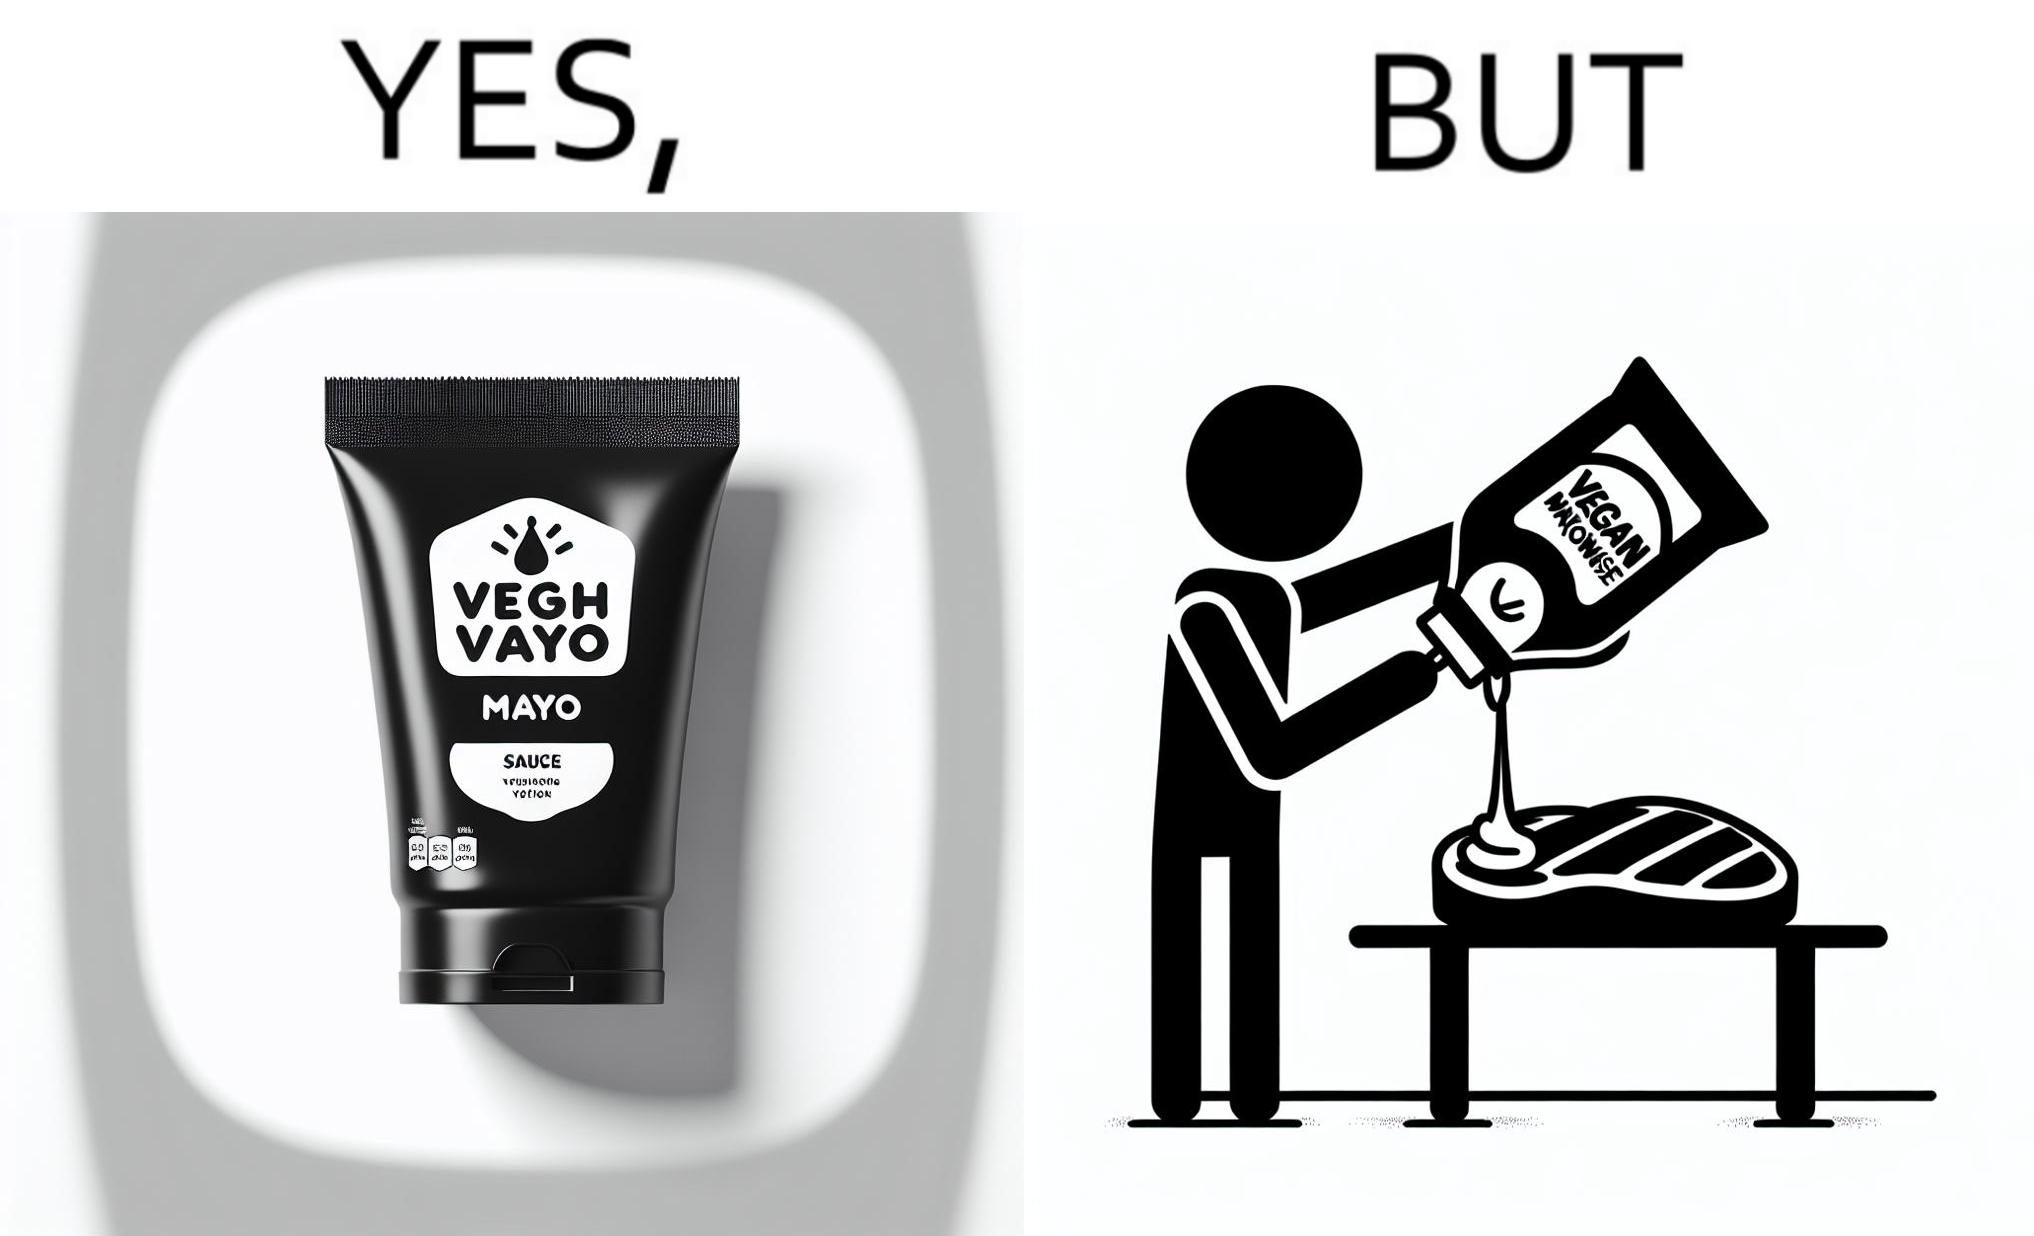What is shown in the left half versus the right half of this image? In the left part of the image: a vegan mayo sauce packet In the right part of the image: pouring vegan mayo sauce from a packet on a rib steak 